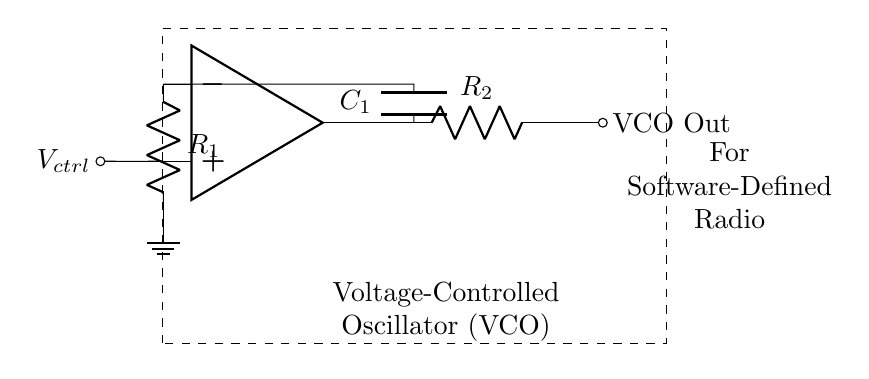What components are used in the circuit? The circuit contains an operational amplifier, a resistor labeled R1, a capacitor labeled C1, and another resistor labeled R2. These components are labeled directly on the diagram.
Answer: operational amplifier, R1, C1, R2 What is the function of the operational amplifier in this circuit? The operational amplifier amplifies the difference between its input terminals and is crucial for the oscillation process in this VCO. Its configuration allows it to control frequency based on the voltage input.
Answer: amplifying What type of oscillator is represented in this circuit? The circuit diagram indicates that this is a voltage-controlled oscillator, as it specifically relies on a control voltage to adjust the output frequency. This is denoted by the presence of the control voltage input connected to the operational amplifier.
Answer: voltage-controlled oscillator What is the output of the VCO indicated in the circuit? The output of the VCO is labeled as "VCO Out," which signifies that this point provides the varying frequency output necessary for the application, such as in software-defined radios.
Answer: VCO Out How does the capacitor contribute to the circuit function? The capacitor (C1) typically functions as part of the timing elements in the oscillator circuit, determining the frequency of oscillation along with the resistors. It charges and discharges, creating oscillations which facilitate signal generation.
Answer: timing element What role does the control voltage play in this circuit? The control voltage (Vctrl) provides an input that adjusts the oscillation frequency of the VCO. By changing this voltage, one can modulate the output frequency of the circuit, making it critical for software-defined radio applications.
Answer: frequency adjustment What is the main application of this VCO circuit? The circuit is primarily used for software-defined radio applications, which require tunable frequency generation to adapt to various communication signals. This is indicated by the label on the diagram.
Answer: software-defined radio 